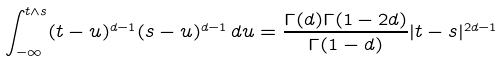Convert formula to latex. <formula><loc_0><loc_0><loc_500><loc_500>\int _ { - \infty } ^ { t \wedge s } ( t - u ) ^ { d - 1 } ( s - u ) ^ { d - 1 } \, d u = \frac { \Gamma ( d ) \Gamma ( 1 - 2 d ) } { \Gamma ( 1 - d ) } | t - s | ^ { 2 d - 1 }</formula> 